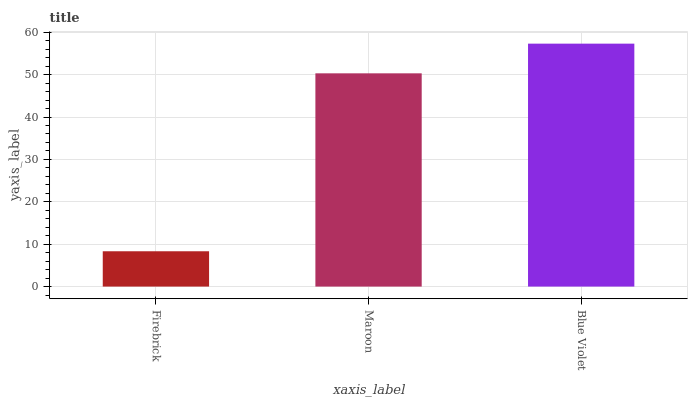Is Firebrick the minimum?
Answer yes or no. Yes. Is Blue Violet the maximum?
Answer yes or no. Yes. Is Maroon the minimum?
Answer yes or no. No. Is Maroon the maximum?
Answer yes or no. No. Is Maroon greater than Firebrick?
Answer yes or no. Yes. Is Firebrick less than Maroon?
Answer yes or no. Yes. Is Firebrick greater than Maroon?
Answer yes or no. No. Is Maroon less than Firebrick?
Answer yes or no. No. Is Maroon the high median?
Answer yes or no. Yes. Is Maroon the low median?
Answer yes or no. Yes. Is Firebrick the high median?
Answer yes or no. No. Is Firebrick the low median?
Answer yes or no. No. 